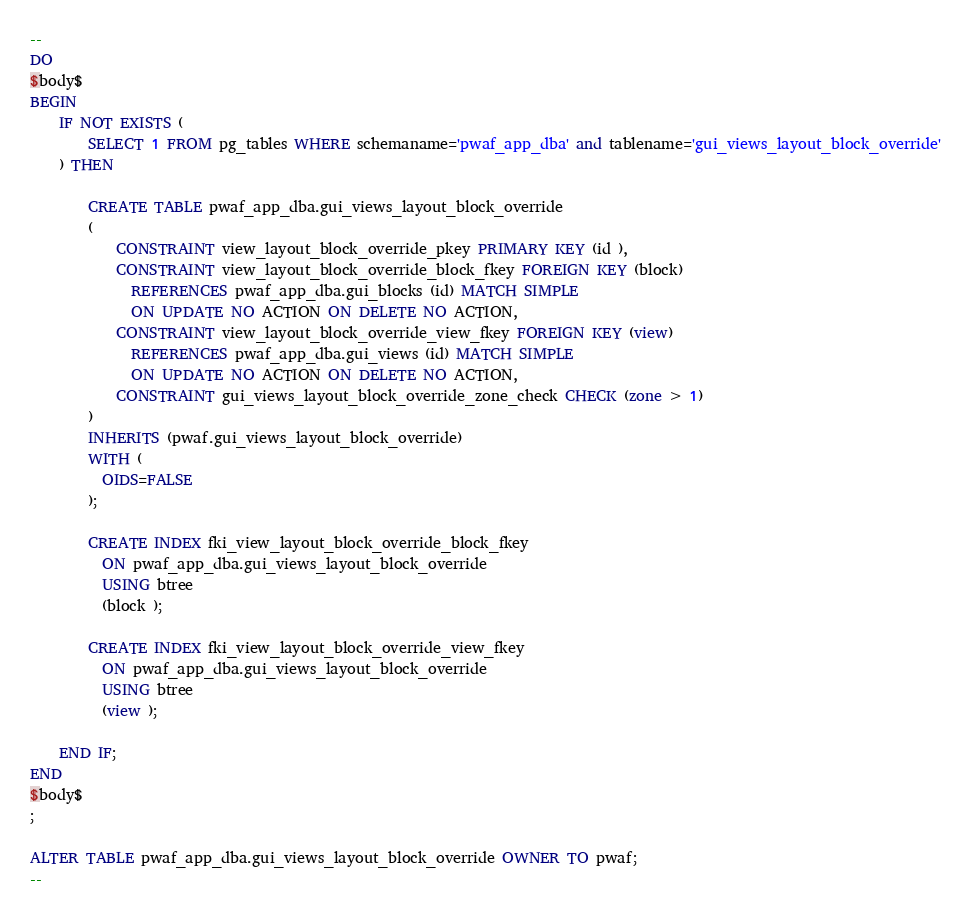<code> <loc_0><loc_0><loc_500><loc_500><_SQL_>--
DO
$body$
BEGIN
	IF NOT EXISTS (
		SELECT 1 FROM pg_tables WHERE schemaname='pwaf_app_dba' and tablename='gui_views_layout_block_override'
	) THEN

		CREATE TABLE pwaf_app_dba.gui_views_layout_block_override
		(
			CONSTRAINT view_layout_block_override_pkey PRIMARY KEY (id ),
			CONSTRAINT view_layout_block_override_block_fkey FOREIGN KEY (block)
			  REFERENCES pwaf_app_dba.gui_blocks (id) MATCH SIMPLE
			  ON UPDATE NO ACTION ON DELETE NO ACTION,
			CONSTRAINT view_layout_block_override_view_fkey FOREIGN KEY (view)
			  REFERENCES pwaf_app_dba.gui_views (id) MATCH SIMPLE
			  ON UPDATE NO ACTION ON DELETE NO ACTION,
			CONSTRAINT gui_views_layout_block_override_zone_check CHECK (zone > 1)
		)
		INHERITS (pwaf.gui_views_layout_block_override)
		WITH (
		  OIDS=FALSE
		);

		CREATE INDEX fki_view_layout_block_override_block_fkey
		  ON pwaf_app_dba.gui_views_layout_block_override
		  USING btree
		  (block );

		CREATE INDEX fki_view_layout_block_override_view_fkey
		  ON pwaf_app_dba.gui_views_layout_block_override
		  USING btree
		  (view );

	END IF;
END
$body$
;

ALTER TABLE pwaf_app_dba.gui_views_layout_block_override OWNER TO pwaf;
--</code> 